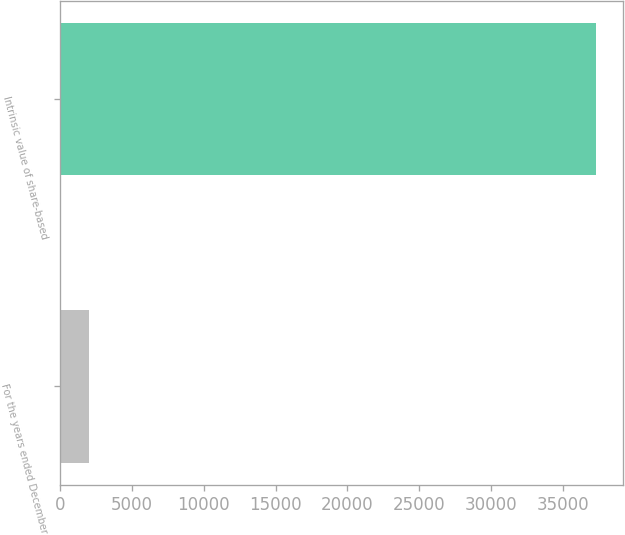<chart> <loc_0><loc_0><loc_500><loc_500><bar_chart><fcel>For the years ended December<fcel>Intrinsic value of share-based<nl><fcel>2012<fcel>37329<nl></chart> 